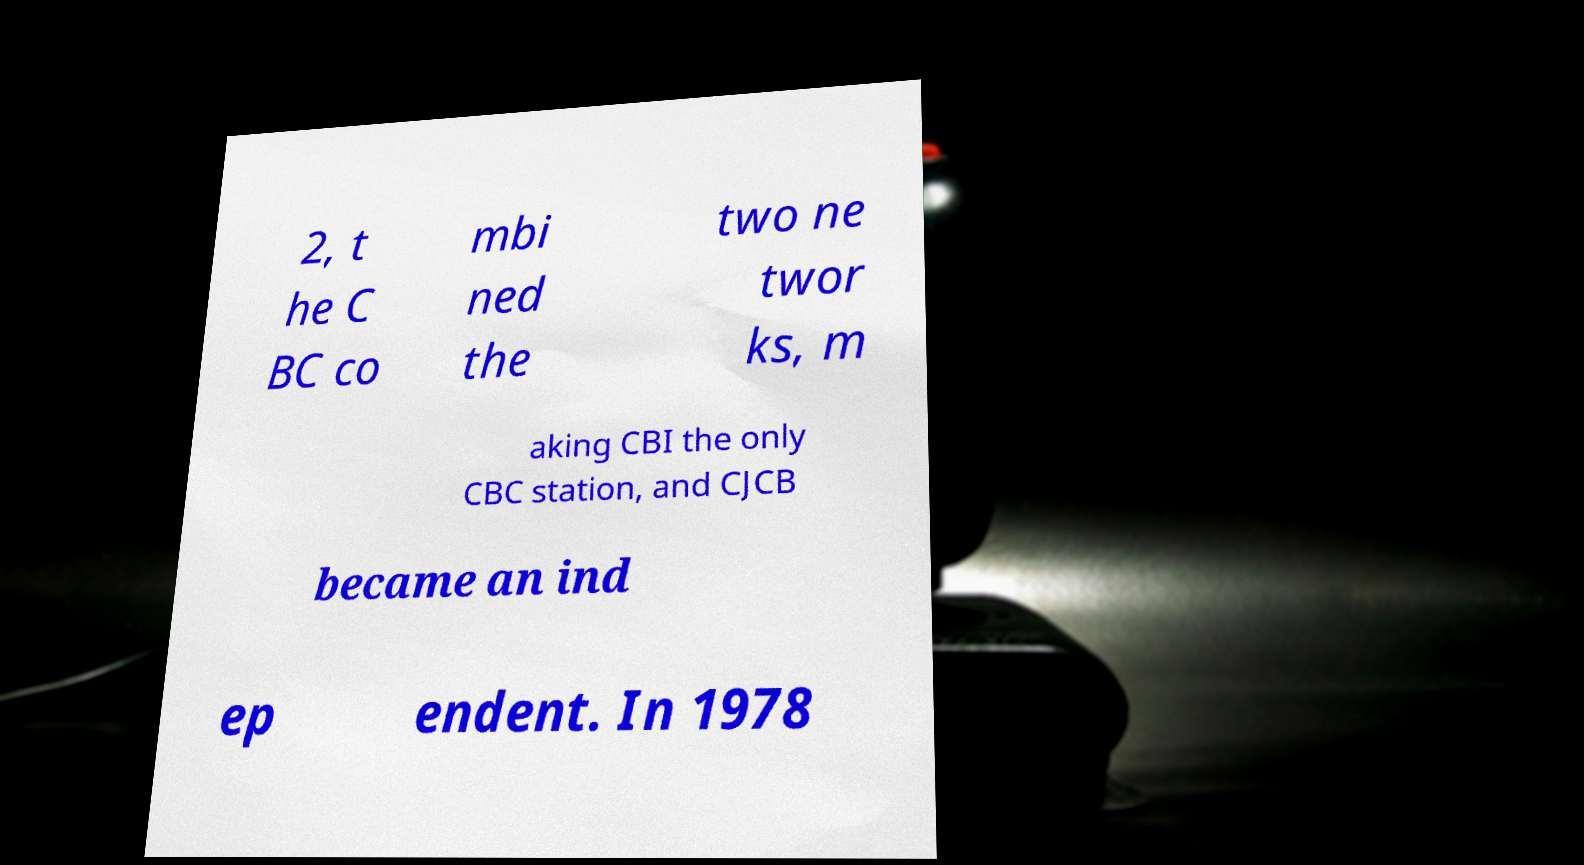Can you accurately transcribe the text from the provided image for me? 2, t he C BC co mbi ned the two ne twor ks, m aking CBI the only CBC station, and CJCB became an ind ep endent. In 1978 